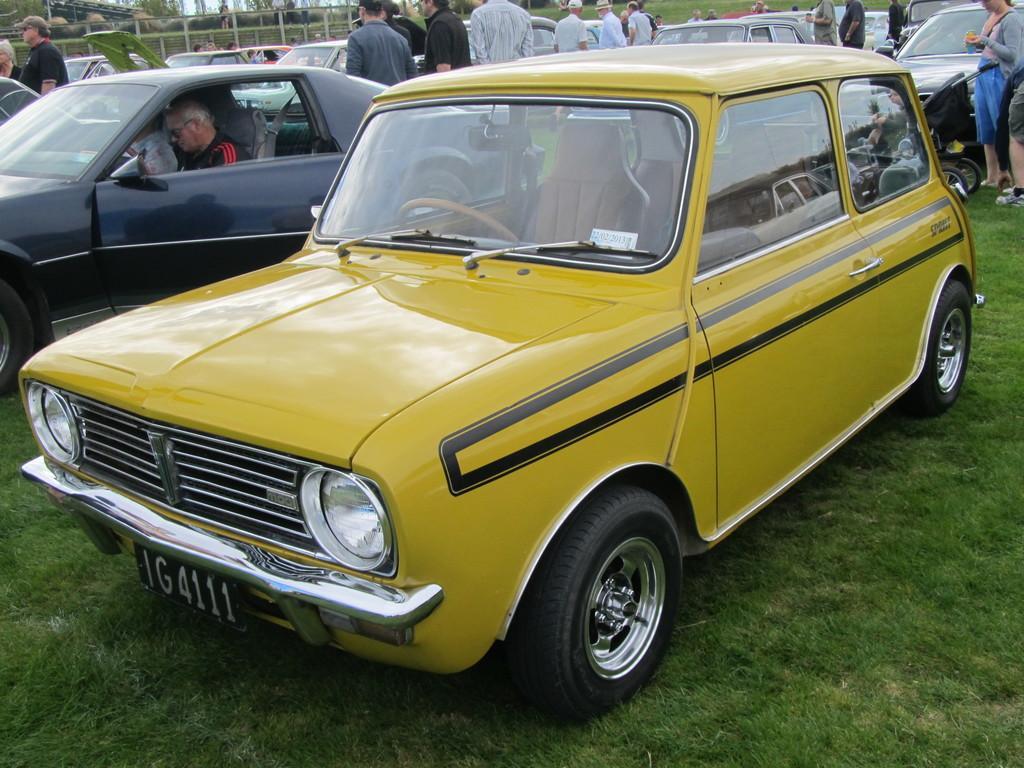In one or two sentences, can you explain what this image depicts? In this image we can see vehicles and there are people. At the bottom there is grass. In the background there is a fence. 